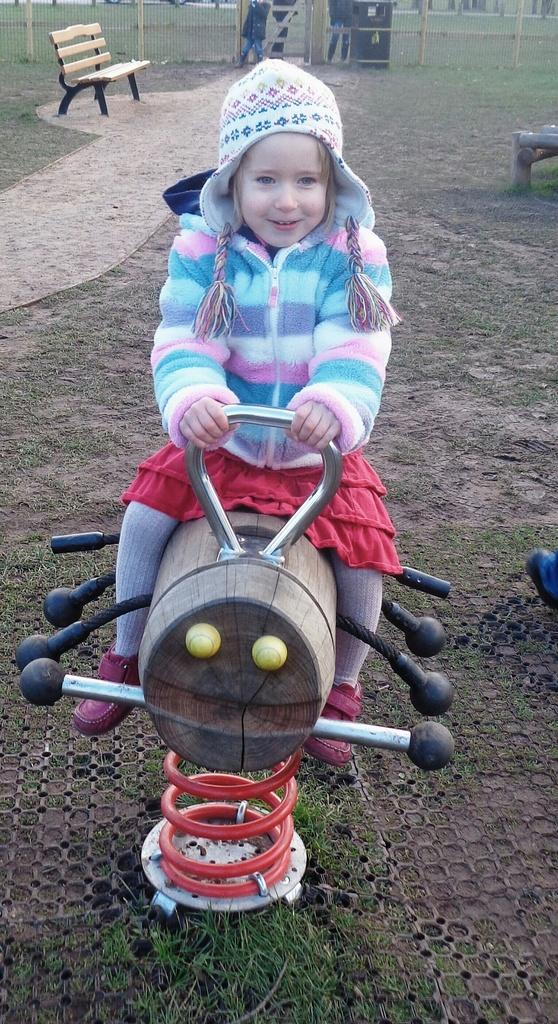Who is the main subject in the image? There is a girl in the image. What is the girl wearing? The girl is wearing a sweater and a cap. What is the girl holding in the image? The girl is holding a toy vehicle. Where is the toy vehicle placed? The toy vehicle is placed on the ground. What can be seen in the background of the image? There is a bench, a fence, a path, and some persons in the background of the image. What type of wrench is the girl using to fix the fence in the image? There is no wrench present in the image, and the girl is not shown fixing the fence. 